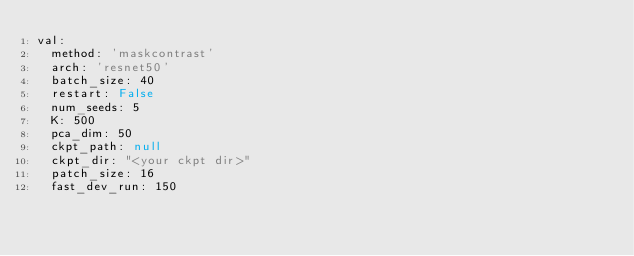Convert code to text. <code><loc_0><loc_0><loc_500><loc_500><_YAML_>val:
  method: 'maskcontrast'
  arch: 'resnet50'
  batch_size: 40
  restart: False
  num_seeds: 5
  K: 500
  pca_dim: 50
  ckpt_path: null
  ckpt_dir: "<your ckpt dir>"
  patch_size: 16
  fast_dev_run: 150
</code> 